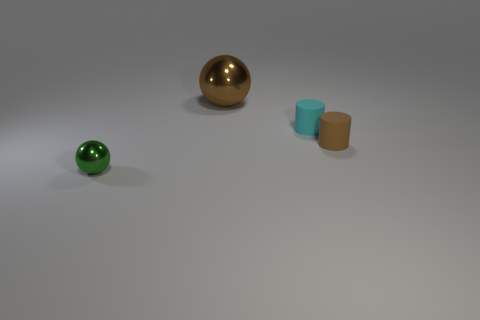Add 2 brown metal balls. How many objects exist? 6 Subtract all brown cylinders. How many cylinders are left? 1 Subtract all gray cubes. How many red spheres are left? 0 Subtract all purple metallic cylinders. Subtract all green things. How many objects are left? 3 Add 3 large brown objects. How many large brown objects are left? 4 Add 4 large blue metal cubes. How many large blue metal cubes exist? 4 Subtract 0 cyan balls. How many objects are left? 4 Subtract all brown cylinders. Subtract all cyan blocks. How many cylinders are left? 1 